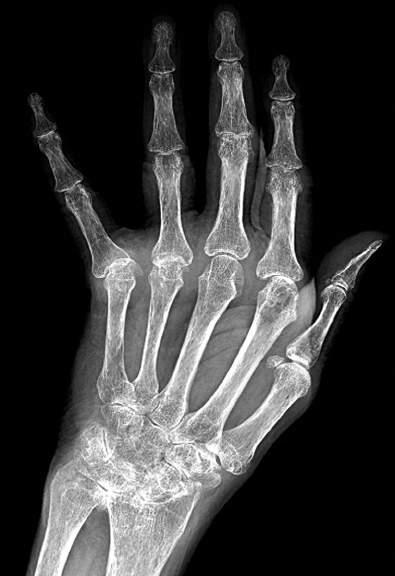what do characteristic features include?
Answer the question using a single word or phrase. Diffuse osteopenia 